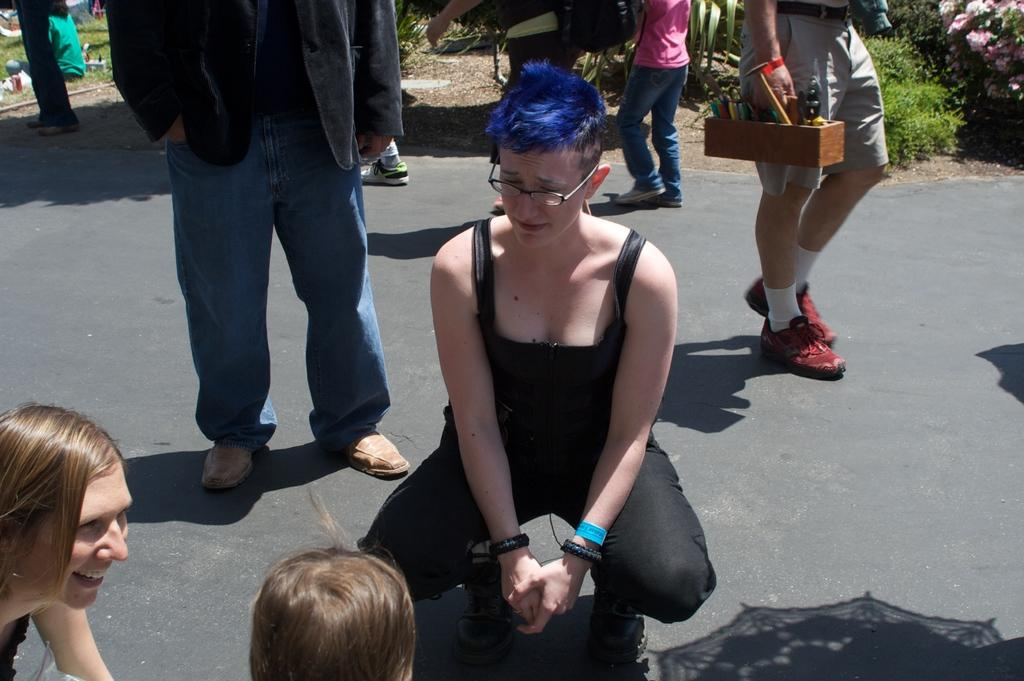What can be seen in the image? There is a group of people in the image. Can you describe one of the individuals in the group? There is a woman in the image, and she is wearing spectacles. What can be seen in the background of the image? There are plants and flowers in the background of the image. What type of tooth is visible in the image? There is no tooth visible in the image. Can you describe the lipstick the woman is wearing in the image? There is no mention of lipstick or any makeup in the image; the woman is only described as wearing spectacles. 